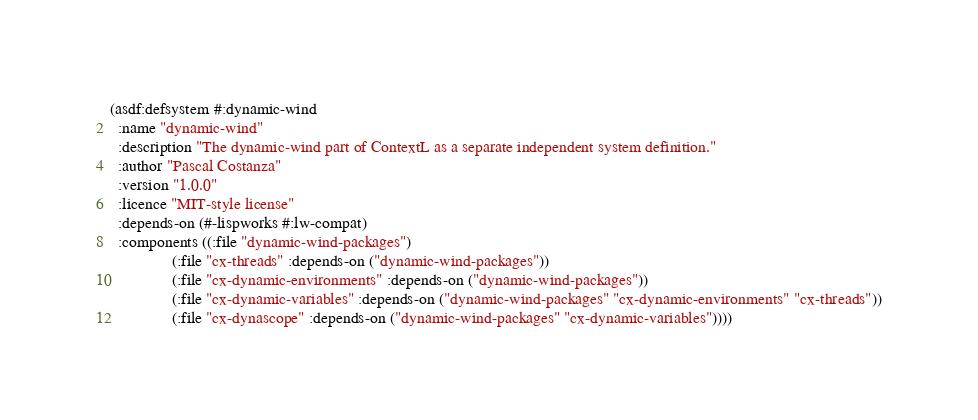<code> <loc_0><loc_0><loc_500><loc_500><_Lisp_>(asdf:defsystem #:dynamic-wind
  :name "dynamic-wind"
  :description "The dynamic-wind part of ContextL as a separate independent system definition."
  :author "Pascal Costanza"
  :version "1.0.0"
  :licence "MIT-style license"
  :depends-on (#-lispworks #:lw-compat)
  :components ((:file "dynamic-wind-packages")
               (:file "cx-threads" :depends-on ("dynamic-wind-packages"))
               (:file "cx-dynamic-environments" :depends-on ("dynamic-wind-packages"))
               (:file "cx-dynamic-variables" :depends-on ("dynamic-wind-packages" "cx-dynamic-environments" "cx-threads"))
               (:file "cx-dynascope" :depends-on ("dynamic-wind-packages" "cx-dynamic-variables"))))
</code> 